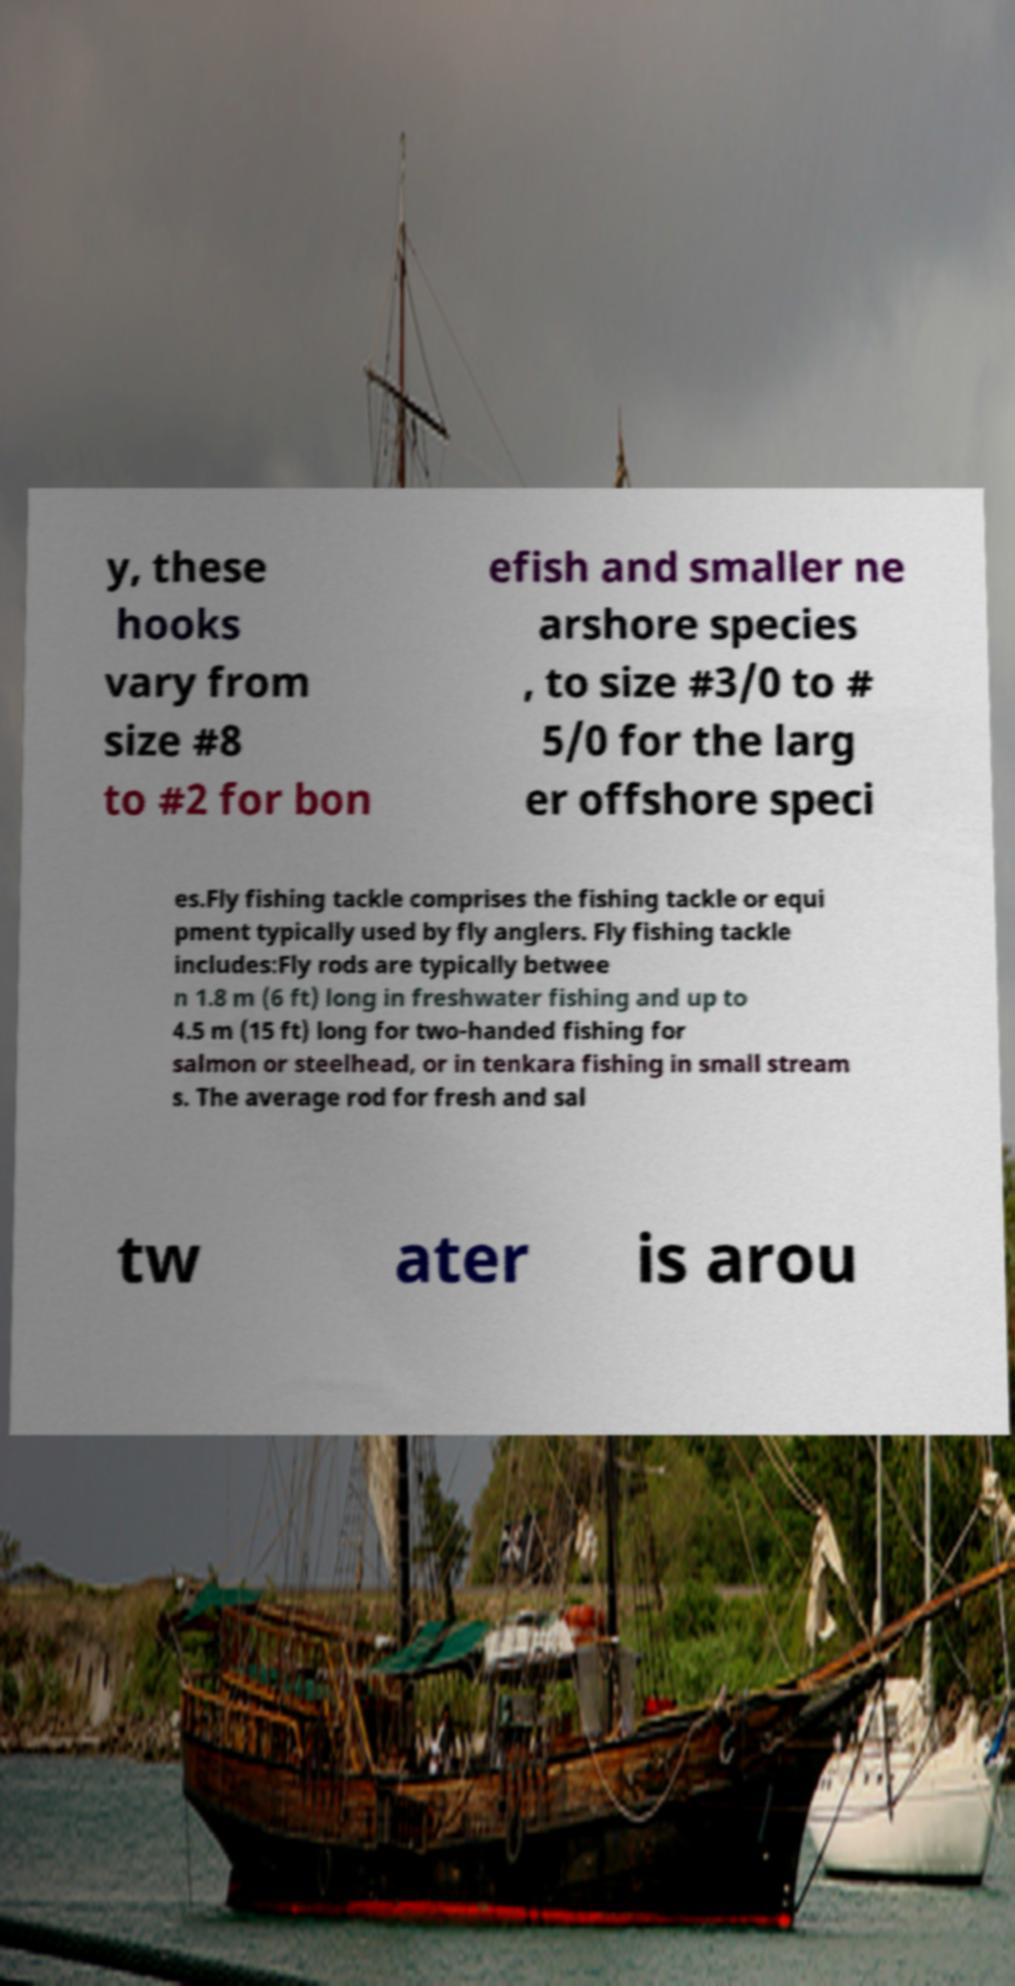Please read and relay the text visible in this image. What does it say? y, these hooks vary from size #8 to #2 for bon efish and smaller ne arshore species , to size #3/0 to # 5/0 for the larg er offshore speci es.Fly fishing tackle comprises the fishing tackle or equi pment typically used by fly anglers. Fly fishing tackle includes:Fly rods are typically betwee n 1.8 m (6 ft) long in freshwater fishing and up to 4.5 m (15 ft) long for two-handed fishing for salmon or steelhead, or in tenkara fishing in small stream s. The average rod for fresh and sal tw ater is arou 